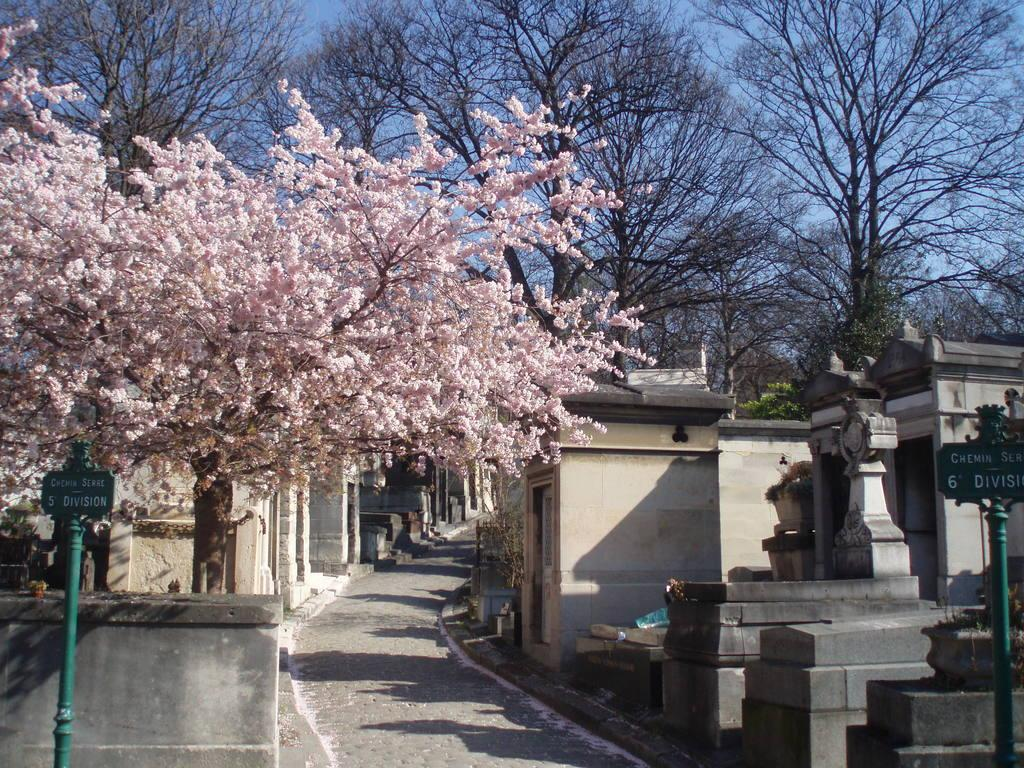What type of tree is present in the image? There is a tree with flowers in the image. What can be found in the vicinity of the tree? There are tombstones in the image. What structures are visible in the image? There are boards attached to poles in the image. How would you describe the setting of the image? The scene appears to be a pathway. What else can be seen in the image besides the tree with flowers? There are trees in the image. Where is the quilt displayed in the image? There is no quilt present in the image. What time is shown on the watch in the image? There is no watch present in the image. 